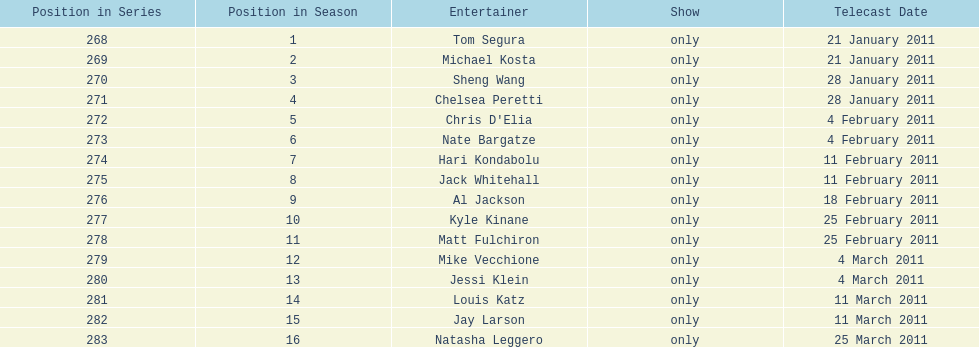Which month had the most performers? February. 